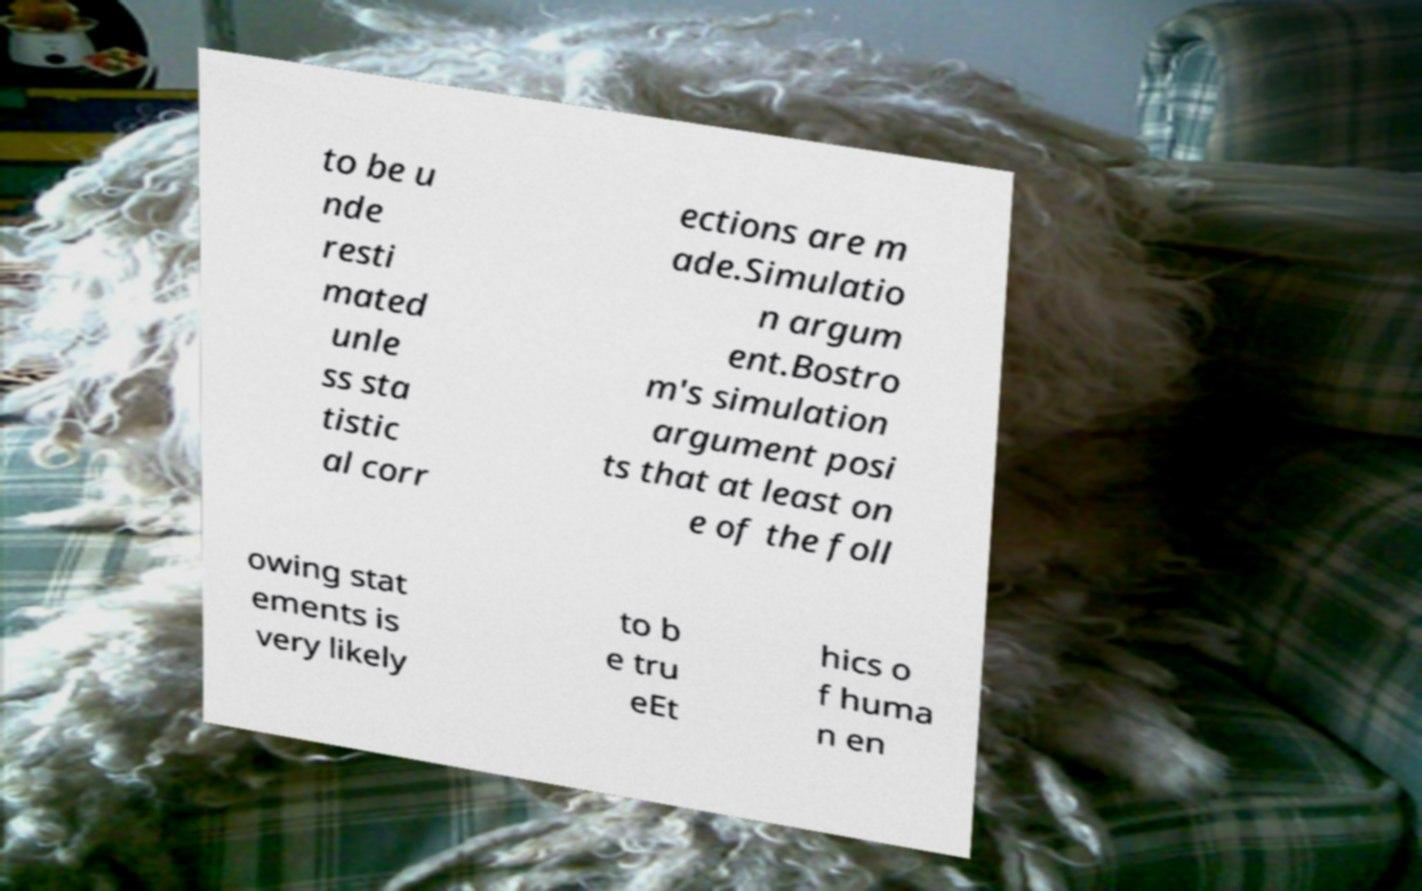Could you extract and type out the text from this image? to be u nde resti mated unle ss sta tistic al corr ections are m ade.Simulatio n argum ent.Bostro m's simulation argument posi ts that at least on e of the foll owing stat ements is very likely to b e tru eEt hics o f huma n en 